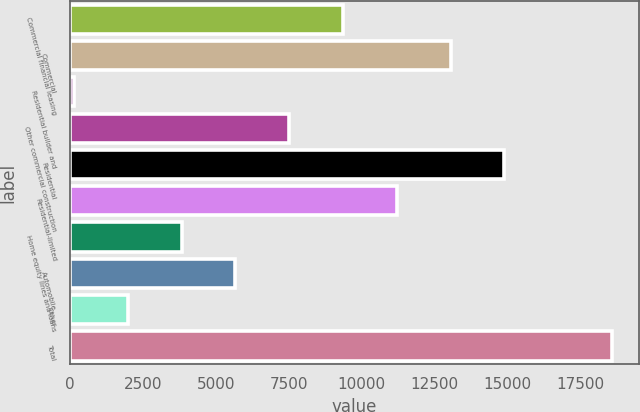<chart> <loc_0><loc_0><loc_500><loc_500><bar_chart><fcel>Commercial financial leasing<fcel>Commercial<fcel>Residential builder and<fcel>Other commercial construction<fcel>Residential<fcel>Residential-limited<fcel>Home equity lines and loans<fcel>Automobile<fcel>Other<fcel>Total<nl><fcel>9357.5<fcel>13043.7<fcel>142<fcel>7514.4<fcel>14886.8<fcel>11200.6<fcel>3828.2<fcel>5671.3<fcel>1985.1<fcel>18573<nl></chart> 